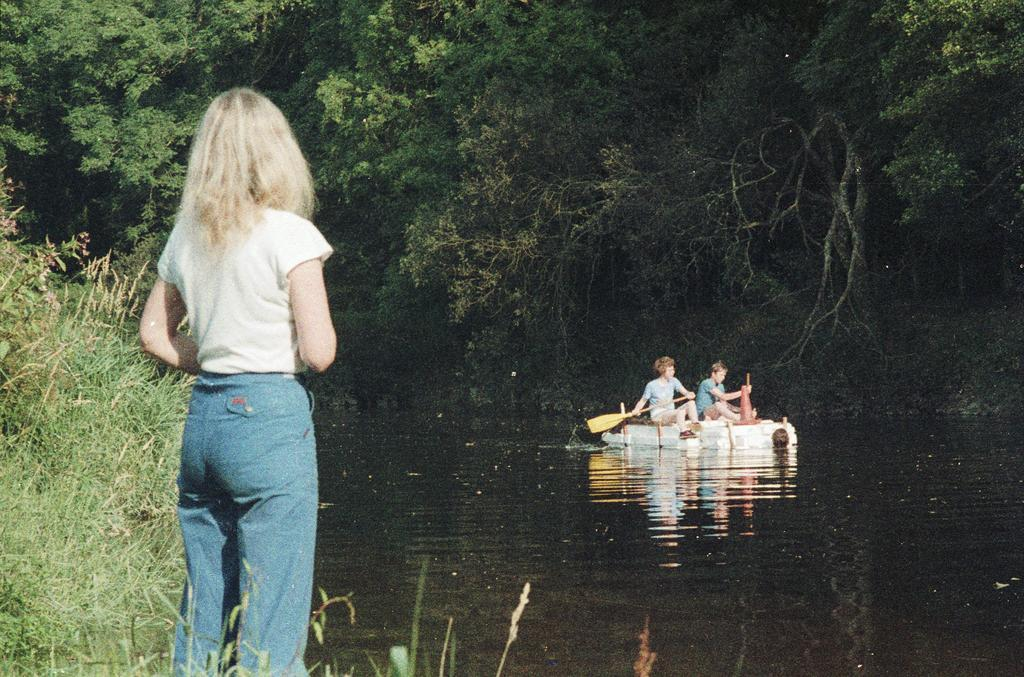Who or what can be seen in the image? There are people in the image. What is the main object in the image? There is a boat in the image. What type of natural environment is visible in the image? There are trees in the image. What body of water is present in the image? There is water visible in the image. What type of club is being used by the people in the image? There is no club visible in the image. What day of the week is it in the image? The day of the week cannot be determined from the image. 